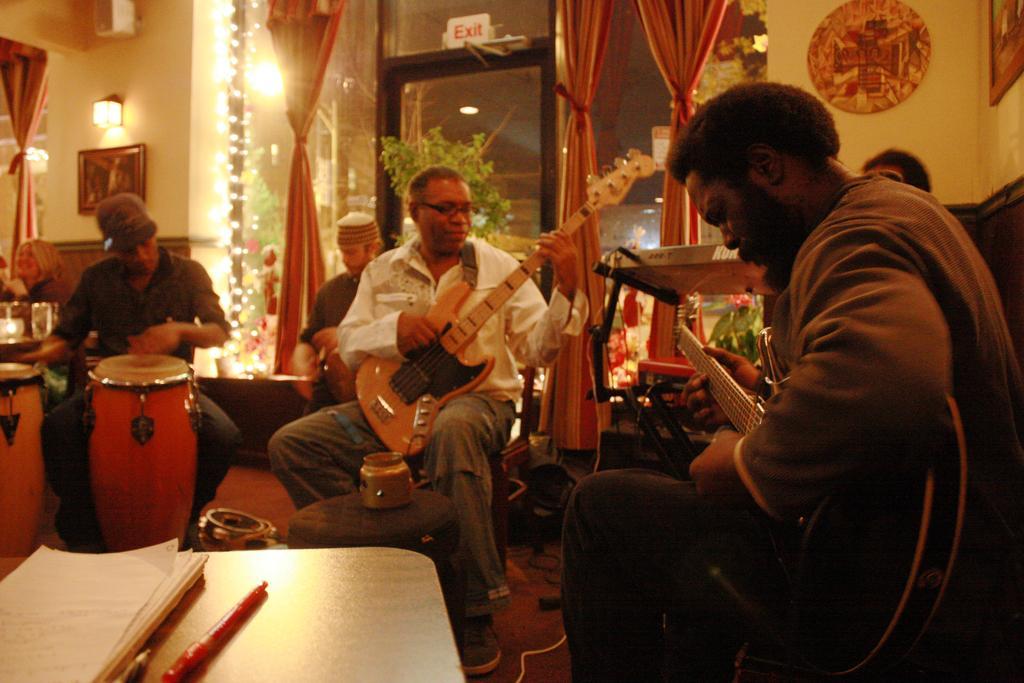Could you give a brief overview of what you see in this image? This picture describes about group of musicians, in the left side of the given image a man is playing drums, and two persons are playing guitar, and other people are also playing musical instruments, in front of them we can find a book and a pen on the table, in the room we can find couple of curtains, lights, wall paintings and a plant. 